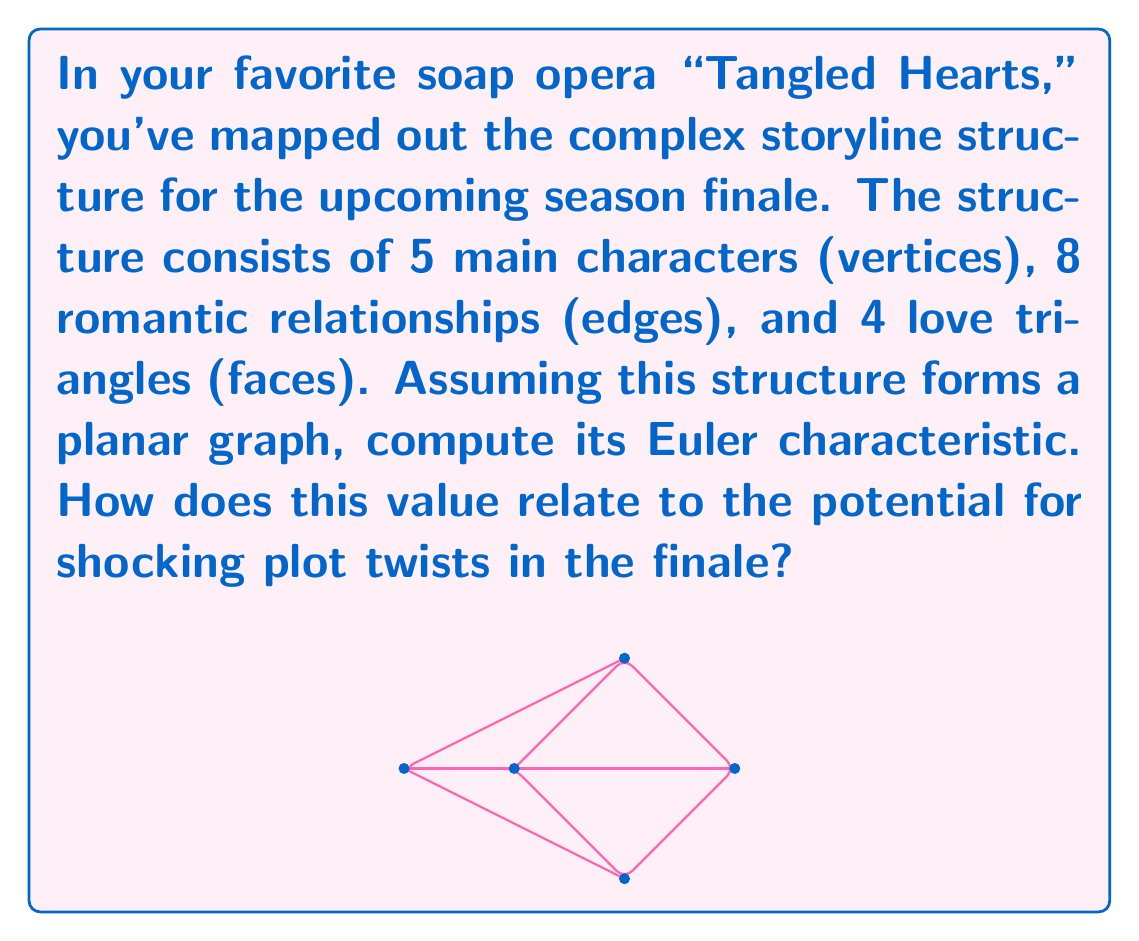What is the answer to this math problem? Let's approach this step-by-step:

1) The Euler characteristic $\chi$ of a planar graph is given by the formula:

   $$\chi = V - E + F$$

   where $V$ is the number of vertices, $E$ is the number of edges, and $F$ is the number of faces.

2) From the given information:
   - $V = 5$ (main characters)
   - $E = 8$ (romantic relationships)
   - $F = 4$ (love triangles) + 1 (outer face) = 5

   Note: We always need to include the outer face in our face count.

3) Now, let's substitute these values into the formula:

   $$\chi = 5 - 8 + 5 = 2$$

4) The Euler characteristic of 2 indicates that this structure is topologically equivalent to a sphere.

5) In soap opera terms, this spherical structure suggests a "well-rounded" plot with potential for unexpected twists. The value of 2 could be interpreted as indicating two major shocking revelations or plot twists in the finale, as the storyline can "wrap around" in surprising ways, just like the surface of a sphere.
Answer: $\chi = 2$ 